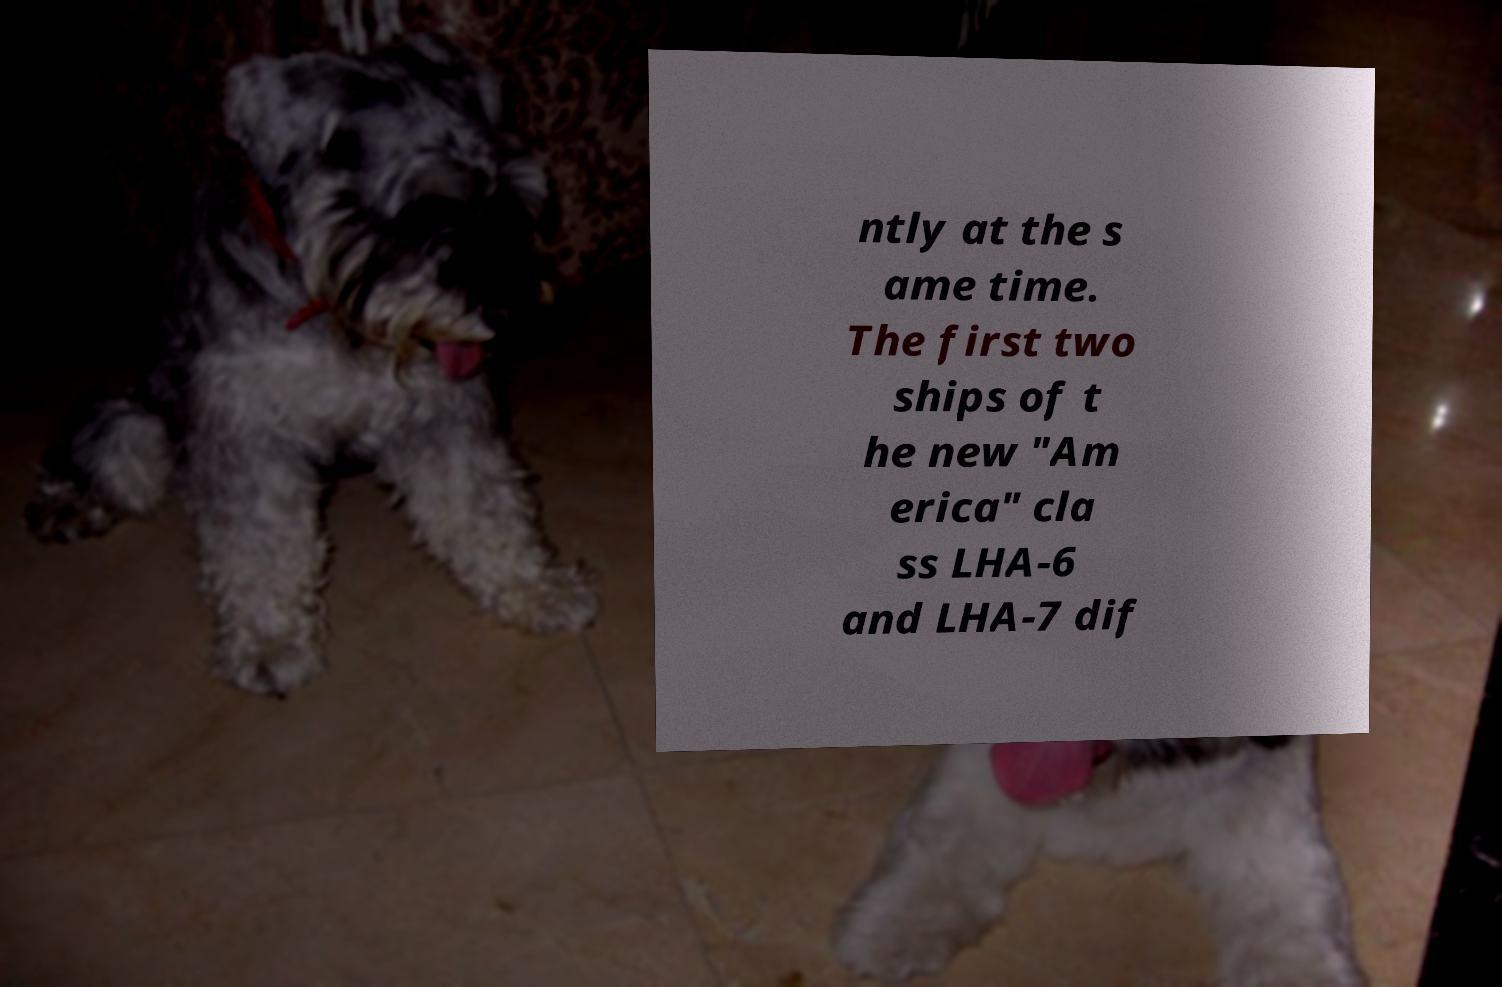Can you read and provide the text displayed in the image?This photo seems to have some interesting text. Can you extract and type it out for me? ntly at the s ame time. The first two ships of t he new "Am erica" cla ss LHA-6 and LHA-7 dif 